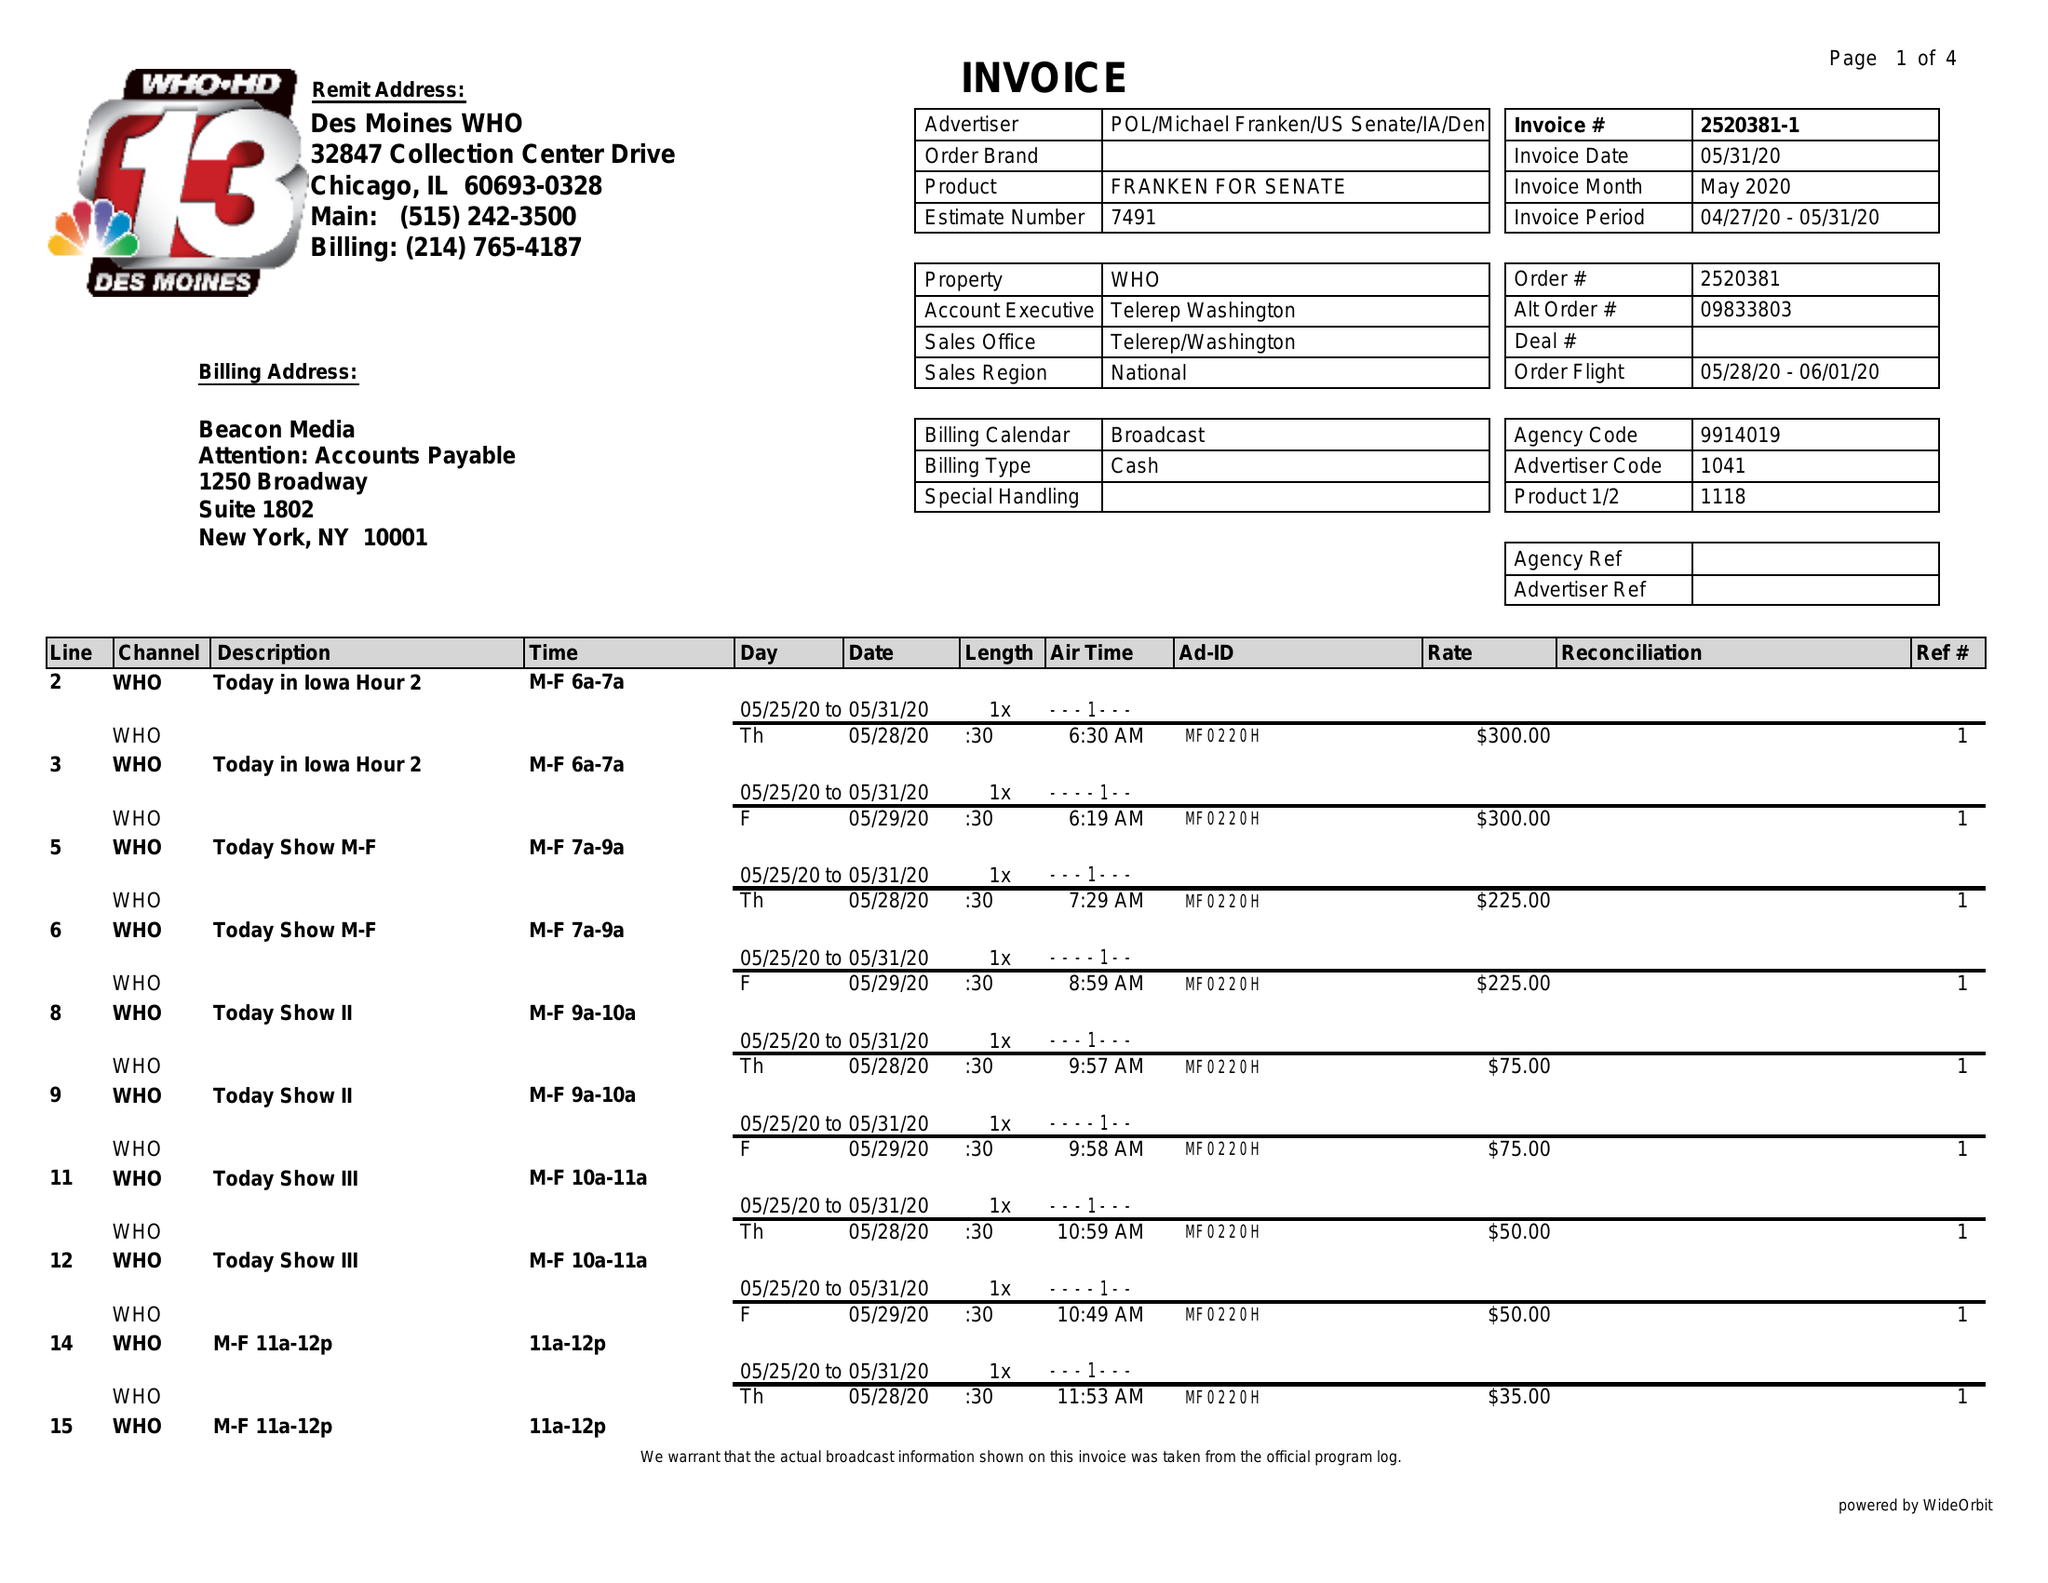What is the value for the gross_amount?
Answer the question using a single word or phrase. 4325.00 